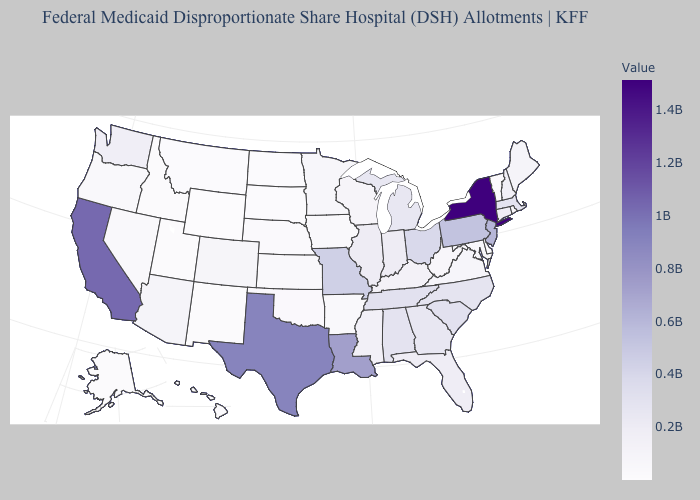Which states hav the highest value in the Northeast?
Give a very brief answer. New York. Does Oklahoma have the highest value in the USA?
Keep it brief. No. Among the states that border Michigan , does Ohio have the lowest value?
Concise answer only. No. Does Alabama have a higher value than California?
Concise answer only. No. Which states have the lowest value in the Northeast?
Answer briefly. Vermont. Which states have the lowest value in the USA?
Write a very short answer. Wyoming. Does Michigan have the highest value in the USA?
Be succinct. No. 